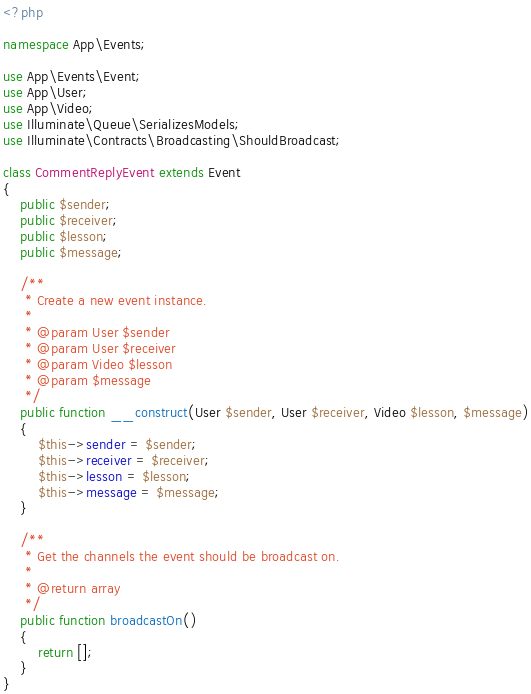Convert code to text. <code><loc_0><loc_0><loc_500><loc_500><_PHP_><?php

namespace App\Events;

use App\Events\Event;
use App\User;
use App\Video;
use Illuminate\Queue\SerializesModels;
use Illuminate\Contracts\Broadcasting\ShouldBroadcast;

class CommentReplyEvent extends Event
{
    public $sender;
    public $receiver;
    public $lesson;
    public $message;

    /**
     * Create a new event instance.
     *
     * @param User $sender
     * @param User $receiver
     * @param Video $lesson
     * @param $message
     */
    public function __construct(User $sender, User $receiver, Video $lesson, $message)
    {
        $this->sender = $sender;
        $this->receiver = $receiver;
        $this->lesson = $lesson;
        $this->message = $message;
    }

    /**
     * Get the channels the event should be broadcast on.
     *
     * @return array
     */
    public function broadcastOn()
    {
        return [];
    }
}
</code> 